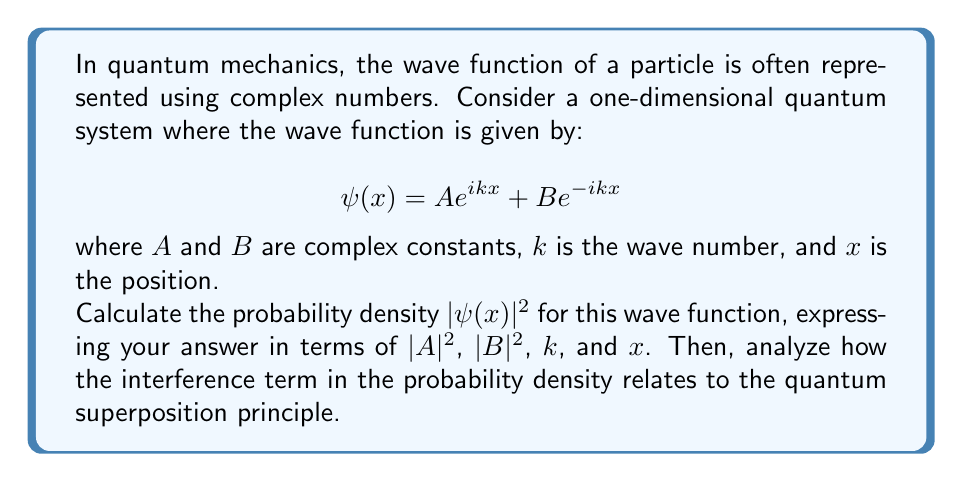Help me with this question. To solve this problem, we'll follow these steps:

1) First, let's recall that the probability density is given by $|\psi(x)|^2 = \psi(x) \cdot \psi^*(x)$, where $\psi^*(x)$ is the complex conjugate of $\psi(x)$.

2) Let's calculate $\psi^*(x)$:
   $$\psi^*(x) = A^*e^{-ikx} + B^*e^{ikx}$$

3) Now, let's multiply $\psi(x)$ and $\psi^*(x)$:

   $$\begin{align*}
   |\psi(x)|^2 &= (Ae^{ikx} + Be^{-ikx})(A^*e^{-ikx} + B^*e^{ikx}) \\
   &= |A|^2e^{ikx}e^{-ikx} + AB^*e^{ikx}e^{ikx} + BA^*e^{-ikx}e^{-ikx} + |B|^2e^{-ikx}e^{ikx} \\
   &= |A|^2 + AB^*e^{2ikx} + BA^*e^{-2ikx} + |B|^2
   \end{align*}$$

4) Note that $AB^*e^{2ikx} + BA^*e^{-2ikx}$ is the complex conjugate of itself, so it's a real number. We can write it as $2\Re(AB^*e^{2ikx})$, where $\Re$ denotes the real part.

5) Using Euler's formula, $e^{2ikx} = \cos(2kx) + i\sin(2kx)$, we can express this term as:

   $$2\Re(AB^*e^{2ikx}) = 2|A||B|\cos(2kx + \theta)$$

   where $\theta$ is the phase difference between $A$ and $B$.

6) Therefore, the final expression for the probability density is:

   $$|\psi(x)|^2 = |A|^2 + |B|^2 + 2|A||B|\cos(2kx + \theta)$$

Analysis of the interference term:
The term $2|A||B|\cos(2kx + \theta)$ represents interference between the two components of the wave function. This interference is a direct manifestation of the quantum superposition principle, which states that if a quantum system can be in multiple states, it can also be in a linear combination of those states.

In this case, $Ae^{ikx}$ and $Be^{-ikx}$ represent two possible states of the system (waves traveling in opposite directions), and their superposition leads to interference in the probability density. This interference can be constructive or destructive depending on the value of $x$, leading to spatial variations in the probability of finding the particle.

The presence of this interference term distinguishes quantum mechanics from classical probability theory. In a classical system, probabilities would simply add, giving $|A|^2 + |B|^2$ without the interference term.
Answer: $$|\psi(x)|^2 = |A|^2 + |B|^2 + 2|A||B|\cos(2kx + \theta)$$
where $\theta$ is the phase difference between $A$ and $B$. The interference term $2|A||B|\cos(2kx + \theta)$ demonstrates the quantum superposition principle, showing how the two components of the wave function interfere to produce spatial variations in the probability density. 